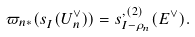<formula> <loc_0><loc_0><loc_500><loc_500>\varpi _ { n * } ( s ^ { \L } _ { I } ( U _ { n } ^ { \vee } ) ) = s ^ { \L , ( 2 ) } _ { I - \rho _ { n } } ( E ^ { \vee } ) .</formula> 